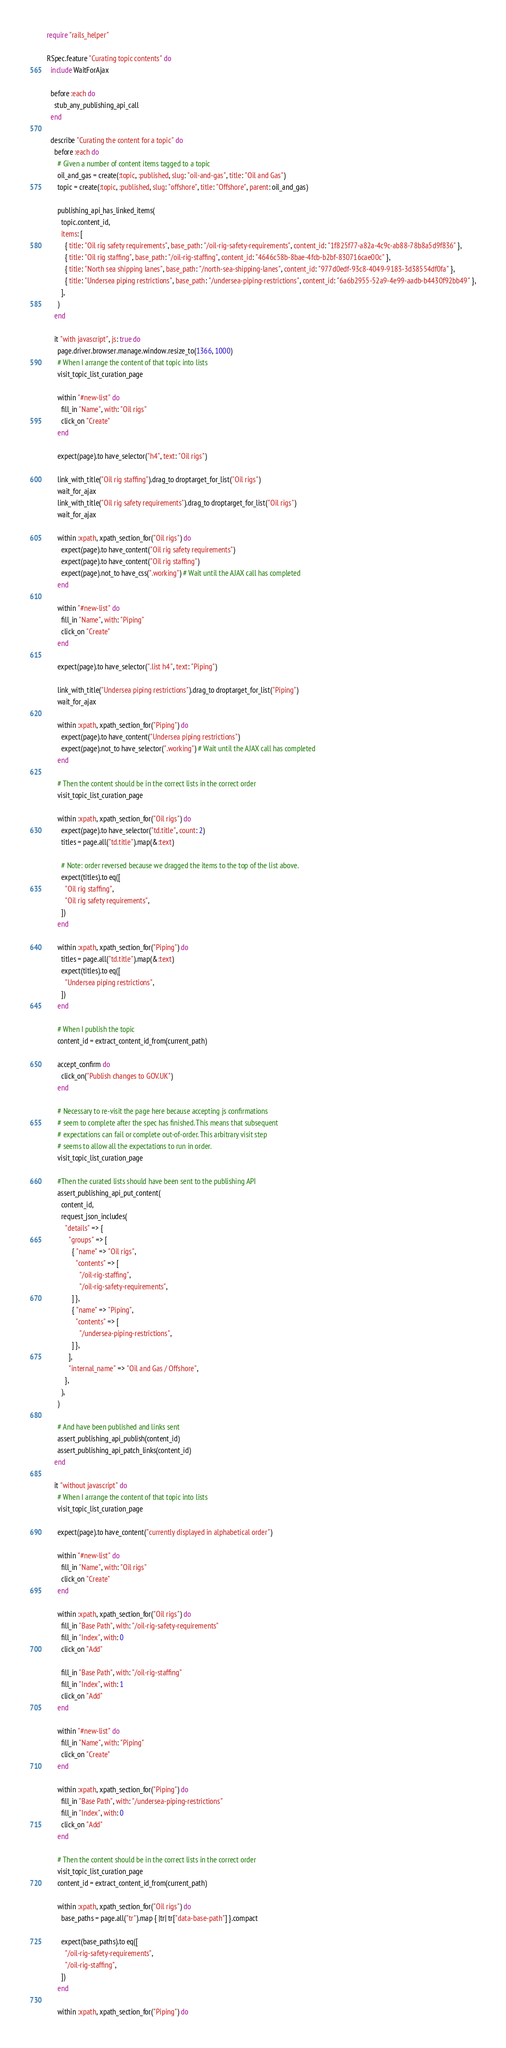Convert code to text. <code><loc_0><loc_0><loc_500><loc_500><_Ruby_>require "rails_helper"

RSpec.feature "Curating topic contents" do
  include WaitForAjax

  before :each do
    stub_any_publishing_api_call
  end

  describe "Curating the content for a topic" do
    before :each do
      # Given a number of content items tagged to a topic
      oil_and_gas = create(:topic, :published, slug: "oil-and-gas", title: "Oil and Gas")
      topic = create(:topic, :published, slug: "offshore", title: "Offshore", parent: oil_and_gas)

      publishing_api_has_linked_items(
        topic.content_id,
        items: [
          { title: "Oil rig safety requirements", base_path: "/oil-rig-safety-requirements", content_id: "1f825f77-a82a-4c9c-ab88-78b8a5d9f836" },
          { title: "Oil rig staffing", base_path: "/oil-rig-staffing", content_id: "4646c58b-8bae-4fcb-b2bf-830716cae00c" },
          { title: "North sea shipping lanes", base_path: "/north-sea-shipping-lanes", content_id: "977d0edf-93c8-4049-9183-3d38554df0fa" },
          { title: "Undersea piping restrictions", base_path: "/undersea-piping-restrictions", content_id: "6a6b2955-52a9-4e99-aadb-b4430f92bb49" },
        ],
      )
    end

    it "with javascript", js: true do
      page.driver.browser.manage.window.resize_to(1366, 1000)
      # When I arrange the content of that topic into lists
      visit_topic_list_curation_page

      within "#new-list" do
        fill_in "Name", with: "Oil rigs"
        click_on "Create"
      end

      expect(page).to have_selector("h4", text: "Oil rigs")

      link_with_title("Oil rig staffing").drag_to droptarget_for_list("Oil rigs")
      wait_for_ajax
      link_with_title("Oil rig safety requirements").drag_to droptarget_for_list("Oil rigs")
      wait_for_ajax

      within :xpath, xpath_section_for("Oil rigs") do
        expect(page).to have_content("Oil rig safety requirements")
        expect(page).to have_content("Oil rig staffing")
        expect(page).not_to have_css(".working") # Wait until the AJAX call has completed
      end

      within "#new-list" do
        fill_in "Name", with: "Piping"
        click_on "Create"
      end

      expect(page).to have_selector(".list h4", text: "Piping")

      link_with_title("Undersea piping restrictions").drag_to droptarget_for_list("Piping")
      wait_for_ajax

      within :xpath, xpath_section_for("Piping") do
        expect(page).to have_content("Undersea piping restrictions")
        expect(page).not_to have_selector(".working") # Wait until the AJAX call has completed
      end

      # Then the content should be in the correct lists in the correct order
      visit_topic_list_curation_page

      within :xpath, xpath_section_for("Oil rigs") do
        expect(page).to have_selector("td.title", count: 2)
        titles = page.all("td.title").map(&:text)

        # Note: order reversed because we dragged the items to the top of the list above.
        expect(titles).to eq([
          "Oil rig staffing",
          "Oil rig safety requirements",
        ])
      end

      within :xpath, xpath_section_for("Piping") do
        titles = page.all("td.title").map(&:text)
        expect(titles).to eq([
          "Undersea piping restrictions",
        ])
      end

      # When I publish the topic
      content_id = extract_content_id_from(current_path)

      accept_confirm do
        click_on("Publish changes to GOV.UK")
      end

      # Necessary to re-visit the page here because accepting js confirmations
      # seem to complete after the spec has finished. This means that subsequent
      # expectations can fail or complete out-of-order. This arbitrary visit step
      # seems to allow all the expectations to run in order.
      visit_topic_list_curation_page

      #Then the curated lists should have been sent to the publishing API
      assert_publishing_api_put_content(
        content_id,
        request_json_includes(
          "details" => {
            "groups" => [
              { "name" => "Oil rigs",
                "contents" => [
                  "/oil-rig-staffing",
                  "/oil-rig-safety-requirements",
              ] },
              { "name" => "Piping",
                "contents" => [
                  "/undersea-piping-restrictions",
              ] },
            ],
            "internal_name" => "Oil and Gas / Offshore",
          },
        ),
      )

      # And have been published and links sent
      assert_publishing_api_publish(content_id)
      assert_publishing_api_patch_links(content_id)
    end

    it "without javascript" do
      # When I arrange the content of that topic into lists
      visit_topic_list_curation_page

      expect(page).to have_content("currently displayed in alphabetical order")

      within "#new-list" do
        fill_in "Name", with: "Oil rigs"
        click_on "Create"
      end

      within :xpath, xpath_section_for("Oil rigs") do
        fill_in "Base Path", with: "/oil-rig-safety-requirements"
        fill_in "Index", with: 0
        click_on "Add"

        fill_in "Base Path", with: "/oil-rig-staffing"
        fill_in "Index", with: 1
        click_on "Add"
      end

      within "#new-list" do
        fill_in "Name", with: "Piping"
        click_on "Create"
      end

      within :xpath, xpath_section_for("Piping") do
        fill_in "Base Path", with: "/undersea-piping-restrictions"
        fill_in "Index", with: 0
        click_on "Add"
      end

      # Then the content should be in the correct lists in the correct order
      visit_topic_list_curation_page
      content_id = extract_content_id_from(current_path)

      within :xpath, xpath_section_for("Oil rigs") do
        base_paths = page.all("tr").map { |tr| tr["data-base-path"] }.compact

        expect(base_paths).to eq([
          "/oil-rig-safety-requirements",
          "/oil-rig-staffing",
        ])
      end

      within :xpath, xpath_section_for("Piping") do</code> 